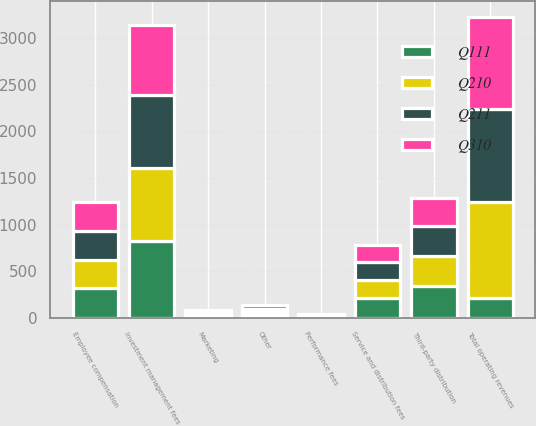<chart> <loc_0><loc_0><loc_500><loc_500><stacked_bar_chart><ecel><fcel>Investment management fees<fcel>Service and distribution fees<fcel>Performance fees<fcel>Other<fcel>Total operating revenues<fcel>Employee compensation<fcel>Third-party distribution<fcel>Marketing<nl><fcel>Q310<fcel>747.6<fcel>181.1<fcel>23.9<fcel>44.5<fcel>997.1<fcel>316.5<fcel>301.8<fcel>21.1<nl><fcel>Q211<fcel>779.5<fcel>189.1<fcel>2.6<fcel>26.6<fcel>997.8<fcel>305.5<fcel>314.4<fcel>13.1<nl><fcel>Q111<fcel>819.1<fcel>211.4<fcel>7.6<fcel>31.9<fcel>211.4<fcel>318.3<fcel>341.8<fcel>26.1<nl><fcel>Q210<fcel>792.3<fcel>198.7<fcel>3.8<fcel>32.5<fcel>1027.3<fcel>305.9<fcel>324.5<fcel>25.7<nl></chart> 